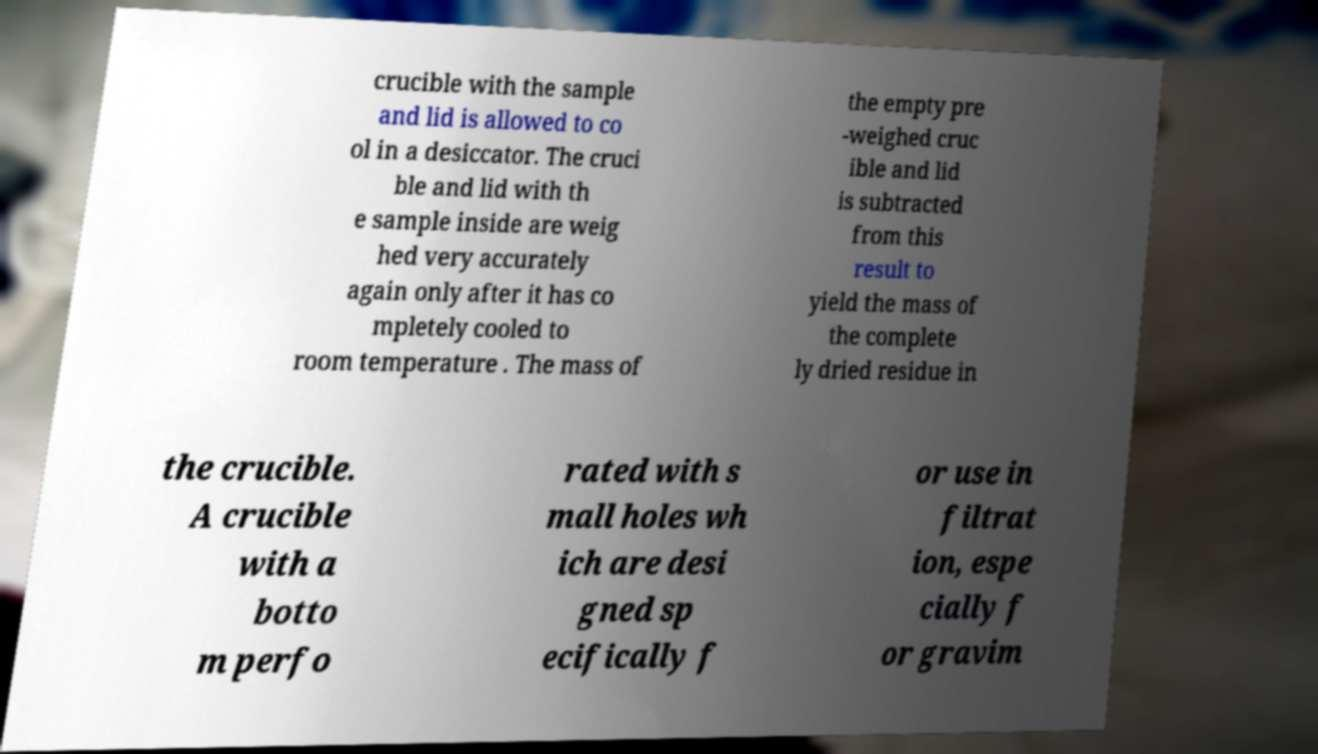Could you assist in decoding the text presented in this image and type it out clearly? crucible with the sample and lid is allowed to co ol in a desiccator. The cruci ble and lid with th e sample inside are weig hed very accurately again only after it has co mpletely cooled to room temperature . The mass of the empty pre -weighed cruc ible and lid is subtracted from this result to yield the mass of the complete ly dried residue in the crucible. A crucible with a botto m perfo rated with s mall holes wh ich are desi gned sp ecifically f or use in filtrat ion, espe cially f or gravim 